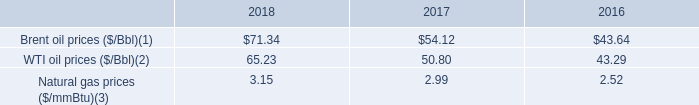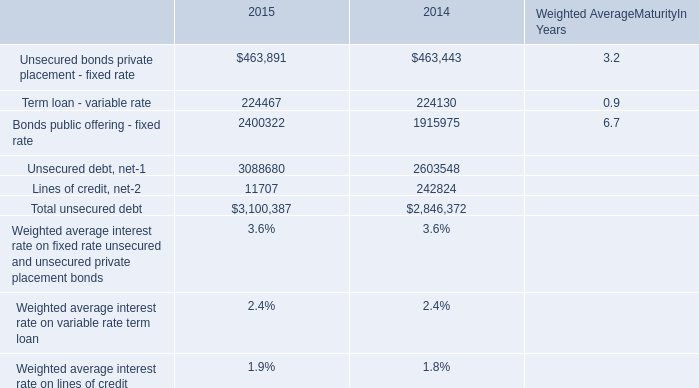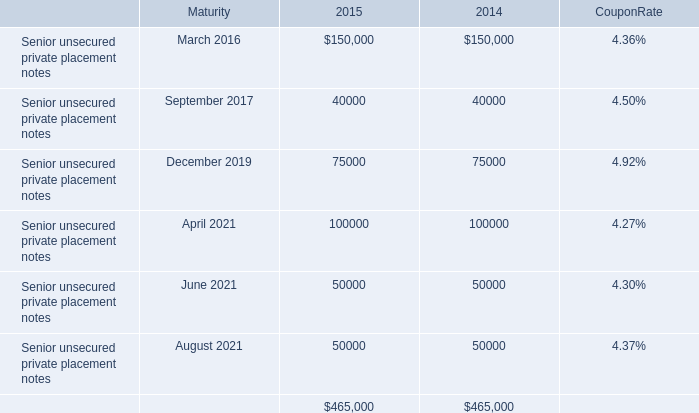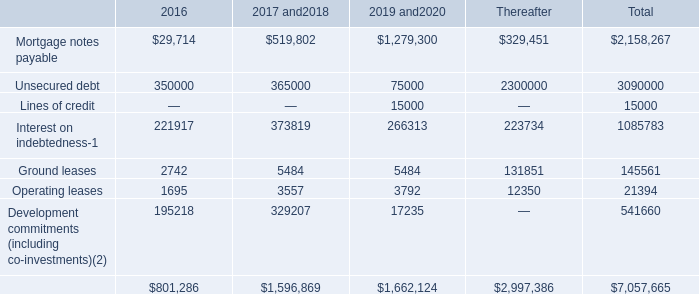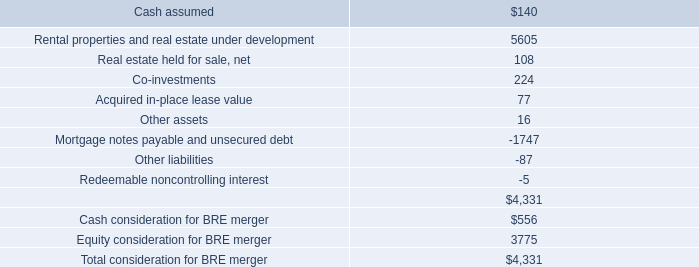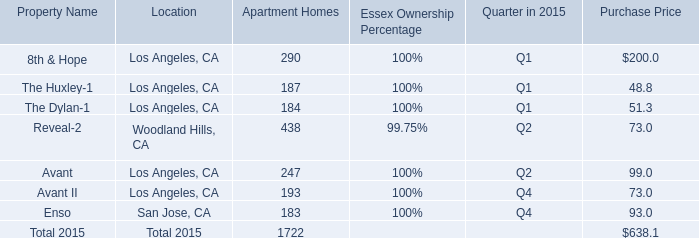What is the proportion of Enso to the total in 2015 for Apartment Homes? 
Computations: (183 / ((((((290 + 187) + 184) + 438) + 247) + 193) + 183))
Answer: 0.10627. 